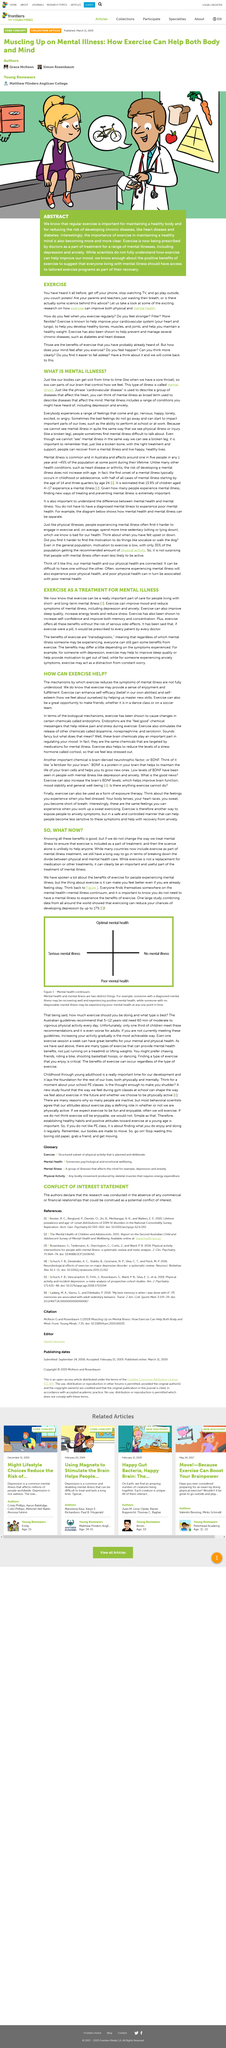Mention a couple of crucial points in this snapshot. Transdiagnostic means that the same principles and techniques can be applied to different mental health conditions, and that exercise can be beneficial for individuals experiencing a variety of different illnesses. Exercise has been shown to reduce the risk of developing depression by up to 17%. The diagram in Figure One, entitled "Mental Health Continuum," is a visual representation of the various aspects of mental health and well-being. Exercise can improve mood and reduce the symptoms of mental illness. Brain-derived neurotrophic factor (BDNF) is a protein in the brain that stimulates the growth and survival of brain cells, functioning as a fertilizer for the brain, promoting the maintenance and generation of new brain cells. 